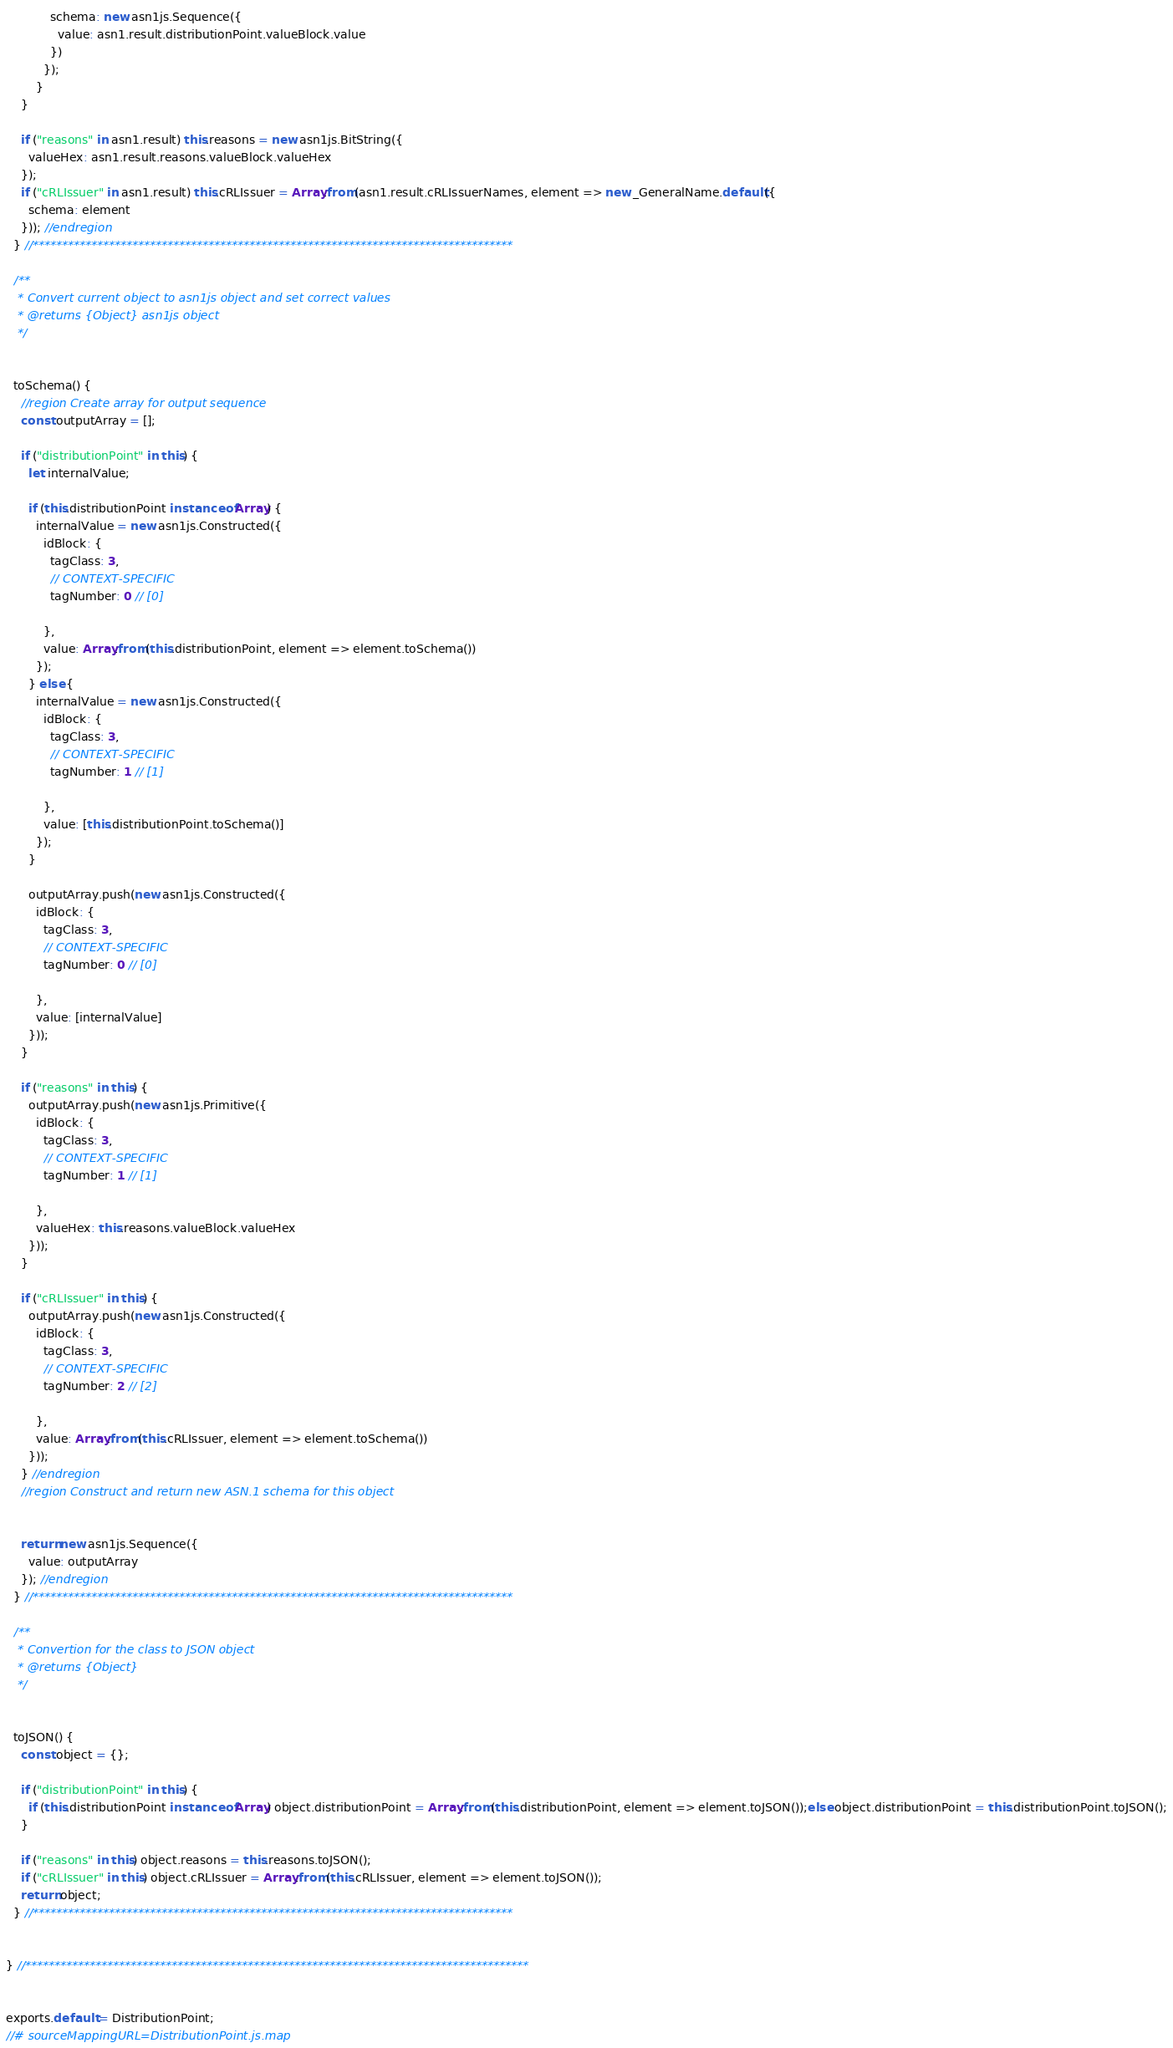Convert code to text. <code><loc_0><loc_0><loc_500><loc_500><_JavaScript_>            schema: new asn1js.Sequence({
              value: asn1.result.distributionPoint.valueBlock.value
            })
          });
        }
    }

    if ("reasons" in asn1.result) this.reasons = new asn1js.BitString({
      valueHex: asn1.result.reasons.valueBlock.valueHex
    });
    if ("cRLIssuer" in asn1.result) this.cRLIssuer = Array.from(asn1.result.cRLIssuerNames, element => new _GeneralName.default({
      schema: element
    })); //endregion
  } //**********************************************************************************

  /**
   * Convert current object to asn1js object and set correct values
   * @returns {Object} asn1js object
   */


  toSchema() {
    //region Create array for output sequence
    const outputArray = [];

    if ("distributionPoint" in this) {
      let internalValue;

      if (this.distributionPoint instanceof Array) {
        internalValue = new asn1js.Constructed({
          idBlock: {
            tagClass: 3,
            // CONTEXT-SPECIFIC
            tagNumber: 0 // [0]

          },
          value: Array.from(this.distributionPoint, element => element.toSchema())
        });
      } else {
        internalValue = new asn1js.Constructed({
          idBlock: {
            tagClass: 3,
            // CONTEXT-SPECIFIC
            tagNumber: 1 // [1]

          },
          value: [this.distributionPoint.toSchema()]
        });
      }

      outputArray.push(new asn1js.Constructed({
        idBlock: {
          tagClass: 3,
          // CONTEXT-SPECIFIC
          tagNumber: 0 // [0]

        },
        value: [internalValue]
      }));
    }

    if ("reasons" in this) {
      outputArray.push(new asn1js.Primitive({
        idBlock: {
          tagClass: 3,
          // CONTEXT-SPECIFIC
          tagNumber: 1 // [1]

        },
        valueHex: this.reasons.valueBlock.valueHex
      }));
    }

    if ("cRLIssuer" in this) {
      outputArray.push(new asn1js.Constructed({
        idBlock: {
          tagClass: 3,
          // CONTEXT-SPECIFIC
          tagNumber: 2 // [2]

        },
        value: Array.from(this.cRLIssuer, element => element.toSchema())
      }));
    } //endregion
    //region Construct and return new ASN.1 schema for this object


    return new asn1js.Sequence({
      value: outputArray
    }); //endregion
  } //**********************************************************************************

  /**
   * Convertion for the class to JSON object
   * @returns {Object}
   */


  toJSON() {
    const object = {};

    if ("distributionPoint" in this) {
      if (this.distributionPoint instanceof Array) object.distributionPoint = Array.from(this.distributionPoint, element => element.toJSON());else object.distributionPoint = this.distributionPoint.toJSON();
    }

    if ("reasons" in this) object.reasons = this.reasons.toJSON();
    if ("cRLIssuer" in this) object.cRLIssuer = Array.from(this.cRLIssuer, element => element.toJSON());
    return object;
  } //**********************************************************************************


} //**************************************************************************************


exports.default = DistributionPoint;
//# sourceMappingURL=DistributionPoint.js.map</code> 